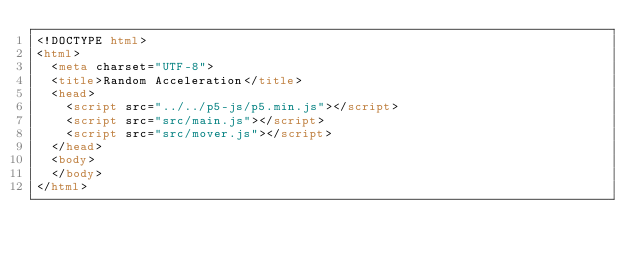<code> <loc_0><loc_0><loc_500><loc_500><_HTML_><!DOCTYPE html>
<html>
	<meta charset="UTF-8">
	<title>Random Acceleration</title>
	<head>
		<script src="../../p5-js/p5.min.js"></script>
		<script src="src/main.js"></script>
		<script src="src/mover.js"></script>
	</head>
	<body>
	</body>
</html>
</code> 